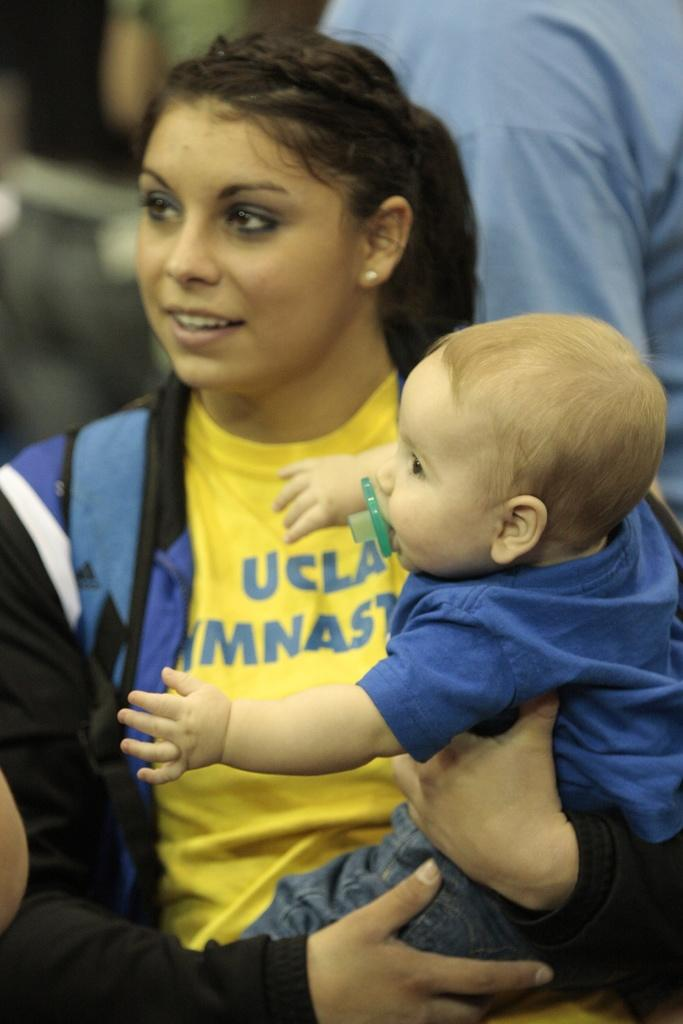What is the woman in the image doing? The woman is sitting and holding a kid in the image. Can you describe the relationship between the woman and the kid? The woman is holding the kid, which suggests a caregiver or parental relationship. Is there anyone else visible in the image? Yes, there is a person visible in the background of the image. What type of advice can be heard being given to the kid in the image? There is no indication in the image that advice is being given to the kid, so it cannot be determined from the picture. 